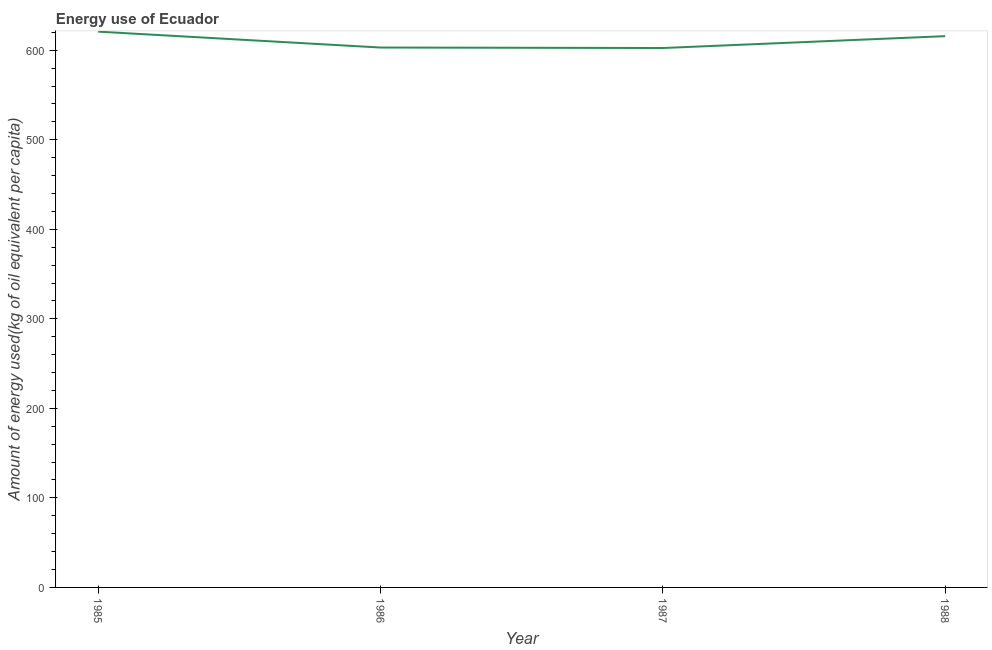What is the amount of energy used in 1986?
Provide a succinct answer. 603.02. Across all years, what is the maximum amount of energy used?
Your answer should be very brief. 620.76. Across all years, what is the minimum amount of energy used?
Offer a terse response. 602.47. In which year was the amount of energy used maximum?
Give a very brief answer. 1985. In which year was the amount of energy used minimum?
Your response must be concise. 1987. What is the sum of the amount of energy used?
Your answer should be compact. 2441.97. What is the difference between the amount of energy used in 1986 and 1988?
Provide a succinct answer. -12.7. What is the average amount of energy used per year?
Your answer should be compact. 610.49. What is the median amount of energy used?
Offer a terse response. 609.37. In how many years, is the amount of energy used greater than 20 kg?
Offer a very short reply. 4. Do a majority of the years between 1985 and 1988 (inclusive) have amount of energy used greater than 160 kg?
Offer a very short reply. Yes. What is the ratio of the amount of energy used in 1985 to that in 1987?
Offer a very short reply. 1.03. Is the amount of energy used in 1985 less than that in 1987?
Give a very brief answer. No. Is the difference between the amount of energy used in 1985 and 1988 greater than the difference between any two years?
Provide a succinct answer. No. What is the difference between the highest and the second highest amount of energy used?
Give a very brief answer. 5.05. What is the difference between the highest and the lowest amount of energy used?
Offer a terse response. 18.29. Does the amount of energy used monotonically increase over the years?
Your answer should be compact. No. How many lines are there?
Your answer should be very brief. 1. What is the difference between two consecutive major ticks on the Y-axis?
Your answer should be compact. 100. Are the values on the major ticks of Y-axis written in scientific E-notation?
Make the answer very short. No. Does the graph contain grids?
Keep it short and to the point. No. What is the title of the graph?
Provide a succinct answer. Energy use of Ecuador. What is the label or title of the Y-axis?
Provide a succinct answer. Amount of energy used(kg of oil equivalent per capita). What is the Amount of energy used(kg of oil equivalent per capita) in 1985?
Your response must be concise. 620.76. What is the Amount of energy used(kg of oil equivalent per capita) in 1986?
Your answer should be very brief. 603.02. What is the Amount of energy used(kg of oil equivalent per capita) of 1987?
Provide a short and direct response. 602.47. What is the Amount of energy used(kg of oil equivalent per capita) of 1988?
Provide a short and direct response. 615.72. What is the difference between the Amount of energy used(kg of oil equivalent per capita) in 1985 and 1986?
Offer a terse response. 17.74. What is the difference between the Amount of energy used(kg of oil equivalent per capita) in 1985 and 1987?
Your response must be concise. 18.29. What is the difference between the Amount of energy used(kg of oil equivalent per capita) in 1985 and 1988?
Offer a terse response. 5.05. What is the difference between the Amount of energy used(kg of oil equivalent per capita) in 1986 and 1987?
Offer a very short reply. 0.55. What is the difference between the Amount of energy used(kg of oil equivalent per capita) in 1986 and 1988?
Make the answer very short. -12.7. What is the difference between the Amount of energy used(kg of oil equivalent per capita) in 1987 and 1988?
Provide a short and direct response. -13.25. What is the ratio of the Amount of energy used(kg of oil equivalent per capita) in 1985 to that in 1986?
Offer a very short reply. 1.03. What is the ratio of the Amount of energy used(kg of oil equivalent per capita) in 1985 to that in 1987?
Provide a short and direct response. 1.03. What is the ratio of the Amount of energy used(kg of oil equivalent per capita) in 1985 to that in 1988?
Your answer should be compact. 1.01. What is the ratio of the Amount of energy used(kg of oil equivalent per capita) in 1986 to that in 1988?
Provide a succinct answer. 0.98. 